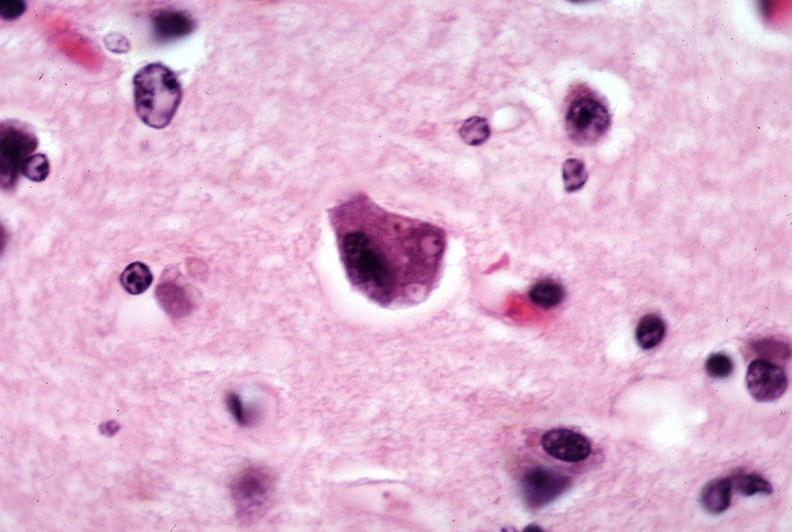where is this?
Answer the question using a single word or phrase. Nervous 